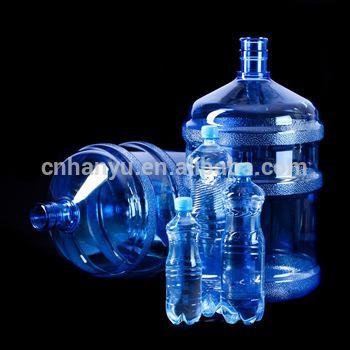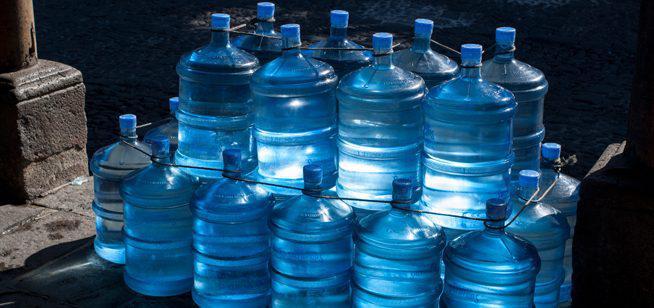The first image is the image on the left, the second image is the image on the right. For the images displayed, is the sentence "Large blue bottles in one image have clear caps and a side hand grip." factually correct? Answer yes or no. No. The first image is the image on the left, the second image is the image on the right. Given the left and right images, does the statement "An image shows at least one water bottle with a loop handle on the lid." hold true? Answer yes or no. No. 